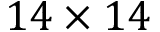<formula> <loc_0><loc_0><loc_500><loc_500>1 4 \times 1 4</formula> 